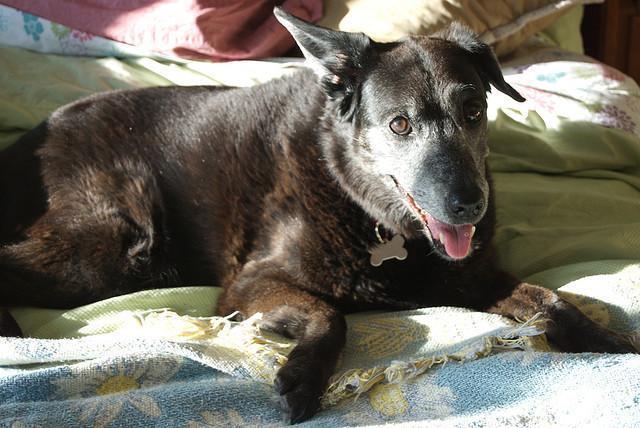How many blankets are under the dog?
Give a very brief answer. 2. How many beds are there?
Give a very brief answer. 1. 